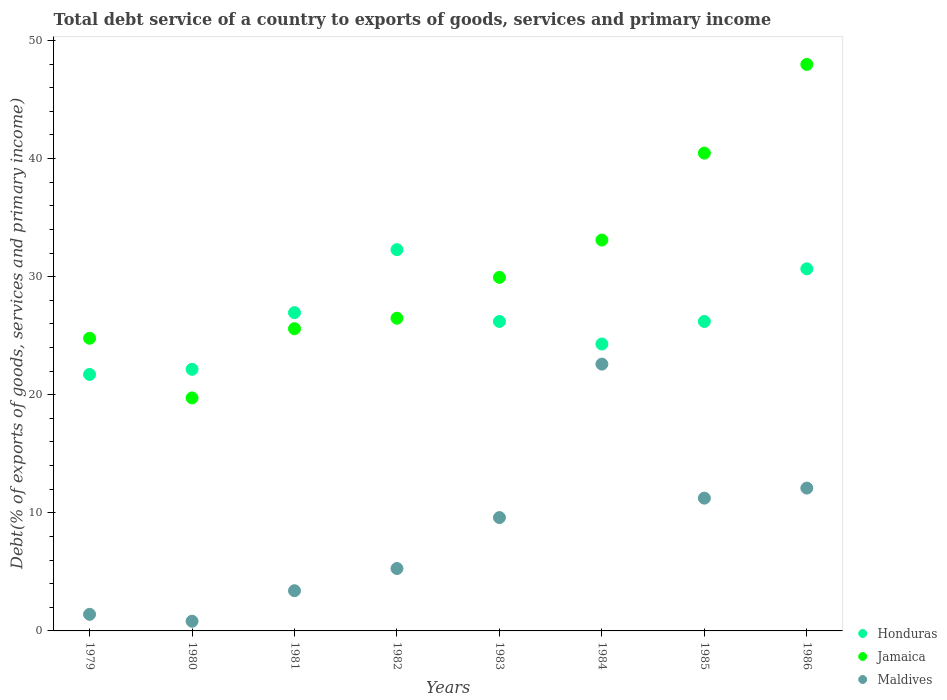What is the total debt service in Maldives in 1981?
Make the answer very short. 3.41. Across all years, what is the maximum total debt service in Honduras?
Ensure brevity in your answer.  32.28. Across all years, what is the minimum total debt service in Maldives?
Offer a very short reply. 0.82. In which year was the total debt service in Jamaica maximum?
Make the answer very short. 1986. In which year was the total debt service in Maldives minimum?
Provide a short and direct response. 1980. What is the total total debt service in Jamaica in the graph?
Give a very brief answer. 248.05. What is the difference between the total debt service in Honduras in 1983 and that in 1984?
Keep it short and to the point. 1.91. What is the difference between the total debt service in Maldives in 1985 and the total debt service in Honduras in 1981?
Make the answer very short. -15.71. What is the average total debt service in Maldives per year?
Offer a very short reply. 8.31. In the year 1983, what is the difference between the total debt service in Jamaica and total debt service in Honduras?
Provide a short and direct response. 3.73. In how many years, is the total debt service in Jamaica greater than 34 %?
Your response must be concise. 2. What is the ratio of the total debt service in Jamaica in 1979 to that in 1980?
Offer a terse response. 1.26. Is the difference between the total debt service in Jamaica in 1984 and 1986 greater than the difference between the total debt service in Honduras in 1984 and 1986?
Ensure brevity in your answer.  No. What is the difference between the highest and the second highest total debt service in Jamaica?
Offer a very short reply. 7.51. What is the difference between the highest and the lowest total debt service in Maldives?
Your answer should be compact. 21.77. Is it the case that in every year, the sum of the total debt service in Honduras and total debt service in Maldives  is greater than the total debt service in Jamaica?
Your answer should be very brief. No. Is the total debt service in Maldives strictly greater than the total debt service in Jamaica over the years?
Ensure brevity in your answer.  No. How many dotlines are there?
Your answer should be compact. 3. How are the legend labels stacked?
Provide a short and direct response. Vertical. What is the title of the graph?
Give a very brief answer. Total debt service of a country to exports of goods, services and primary income. What is the label or title of the X-axis?
Make the answer very short. Years. What is the label or title of the Y-axis?
Make the answer very short. Debt(% of exports of goods, services and primary income). What is the Debt(% of exports of goods, services and primary income) in Honduras in 1979?
Offer a very short reply. 21.72. What is the Debt(% of exports of goods, services and primary income) of Jamaica in 1979?
Provide a succinct answer. 24.78. What is the Debt(% of exports of goods, services and primary income) of Maldives in 1979?
Your response must be concise. 1.4. What is the Debt(% of exports of goods, services and primary income) of Honduras in 1980?
Your answer should be very brief. 22.15. What is the Debt(% of exports of goods, services and primary income) in Jamaica in 1980?
Make the answer very short. 19.73. What is the Debt(% of exports of goods, services and primary income) of Maldives in 1980?
Provide a succinct answer. 0.82. What is the Debt(% of exports of goods, services and primary income) in Honduras in 1981?
Keep it short and to the point. 26.95. What is the Debt(% of exports of goods, services and primary income) in Jamaica in 1981?
Offer a very short reply. 25.59. What is the Debt(% of exports of goods, services and primary income) of Maldives in 1981?
Your answer should be very brief. 3.41. What is the Debt(% of exports of goods, services and primary income) of Honduras in 1982?
Offer a terse response. 32.28. What is the Debt(% of exports of goods, services and primary income) in Jamaica in 1982?
Ensure brevity in your answer.  26.48. What is the Debt(% of exports of goods, services and primary income) in Maldives in 1982?
Your answer should be very brief. 5.28. What is the Debt(% of exports of goods, services and primary income) in Honduras in 1983?
Offer a terse response. 26.2. What is the Debt(% of exports of goods, services and primary income) in Jamaica in 1983?
Offer a terse response. 29.94. What is the Debt(% of exports of goods, services and primary income) of Maldives in 1983?
Make the answer very short. 9.6. What is the Debt(% of exports of goods, services and primary income) of Honduras in 1984?
Your answer should be very brief. 24.29. What is the Debt(% of exports of goods, services and primary income) in Jamaica in 1984?
Offer a very short reply. 33.1. What is the Debt(% of exports of goods, services and primary income) in Maldives in 1984?
Provide a succinct answer. 22.59. What is the Debt(% of exports of goods, services and primary income) in Honduras in 1985?
Provide a succinct answer. 26.2. What is the Debt(% of exports of goods, services and primary income) in Jamaica in 1985?
Provide a succinct answer. 40.46. What is the Debt(% of exports of goods, services and primary income) of Maldives in 1985?
Your answer should be very brief. 11.24. What is the Debt(% of exports of goods, services and primary income) of Honduras in 1986?
Keep it short and to the point. 30.66. What is the Debt(% of exports of goods, services and primary income) in Jamaica in 1986?
Offer a terse response. 47.97. What is the Debt(% of exports of goods, services and primary income) in Maldives in 1986?
Offer a terse response. 12.1. Across all years, what is the maximum Debt(% of exports of goods, services and primary income) of Honduras?
Keep it short and to the point. 32.28. Across all years, what is the maximum Debt(% of exports of goods, services and primary income) in Jamaica?
Give a very brief answer. 47.97. Across all years, what is the maximum Debt(% of exports of goods, services and primary income) of Maldives?
Ensure brevity in your answer.  22.59. Across all years, what is the minimum Debt(% of exports of goods, services and primary income) in Honduras?
Give a very brief answer. 21.72. Across all years, what is the minimum Debt(% of exports of goods, services and primary income) in Jamaica?
Your answer should be compact. 19.73. Across all years, what is the minimum Debt(% of exports of goods, services and primary income) in Maldives?
Your answer should be very brief. 0.82. What is the total Debt(% of exports of goods, services and primary income) of Honduras in the graph?
Give a very brief answer. 210.47. What is the total Debt(% of exports of goods, services and primary income) of Jamaica in the graph?
Offer a very short reply. 248.05. What is the total Debt(% of exports of goods, services and primary income) of Maldives in the graph?
Your answer should be very brief. 66.44. What is the difference between the Debt(% of exports of goods, services and primary income) of Honduras in 1979 and that in 1980?
Your response must be concise. -0.43. What is the difference between the Debt(% of exports of goods, services and primary income) of Jamaica in 1979 and that in 1980?
Your response must be concise. 5.05. What is the difference between the Debt(% of exports of goods, services and primary income) of Maldives in 1979 and that in 1980?
Offer a very short reply. 0.58. What is the difference between the Debt(% of exports of goods, services and primary income) of Honduras in 1979 and that in 1981?
Keep it short and to the point. -5.23. What is the difference between the Debt(% of exports of goods, services and primary income) in Jamaica in 1979 and that in 1981?
Offer a very short reply. -0.81. What is the difference between the Debt(% of exports of goods, services and primary income) of Maldives in 1979 and that in 1981?
Provide a succinct answer. -2. What is the difference between the Debt(% of exports of goods, services and primary income) of Honduras in 1979 and that in 1982?
Give a very brief answer. -10.56. What is the difference between the Debt(% of exports of goods, services and primary income) in Jamaica in 1979 and that in 1982?
Give a very brief answer. -1.7. What is the difference between the Debt(% of exports of goods, services and primary income) in Maldives in 1979 and that in 1982?
Provide a short and direct response. -3.88. What is the difference between the Debt(% of exports of goods, services and primary income) of Honduras in 1979 and that in 1983?
Your answer should be very brief. -4.48. What is the difference between the Debt(% of exports of goods, services and primary income) of Jamaica in 1979 and that in 1983?
Provide a succinct answer. -5.15. What is the difference between the Debt(% of exports of goods, services and primary income) of Maldives in 1979 and that in 1983?
Make the answer very short. -8.19. What is the difference between the Debt(% of exports of goods, services and primary income) of Honduras in 1979 and that in 1984?
Your answer should be compact. -2.58. What is the difference between the Debt(% of exports of goods, services and primary income) in Jamaica in 1979 and that in 1984?
Ensure brevity in your answer.  -8.32. What is the difference between the Debt(% of exports of goods, services and primary income) in Maldives in 1979 and that in 1984?
Your answer should be very brief. -21.19. What is the difference between the Debt(% of exports of goods, services and primary income) in Honduras in 1979 and that in 1985?
Provide a succinct answer. -4.49. What is the difference between the Debt(% of exports of goods, services and primary income) of Jamaica in 1979 and that in 1985?
Provide a succinct answer. -15.68. What is the difference between the Debt(% of exports of goods, services and primary income) of Maldives in 1979 and that in 1985?
Your response must be concise. -9.84. What is the difference between the Debt(% of exports of goods, services and primary income) of Honduras in 1979 and that in 1986?
Make the answer very short. -8.94. What is the difference between the Debt(% of exports of goods, services and primary income) in Jamaica in 1979 and that in 1986?
Offer a very short reply. -23.19. What is the difference between the Debt(% of exports of goods, services and primary income) in Maldives in 1979 and that in 1986?
Make the answer very short. -10.69. What is the difference between the Debt(% of exports of goods, services and primary income) of Honduras in 1980 and that in 1981?
Your answer should be very brief. -4.8. What is the difference between the Debt(% of exports of goods, services and primary income) of Jamaica in 1980 and that in 1981?
Offer a terse response. -5.86. What is the difference between the Debt(% of exports of goods, services and primary income) in Maldives in 1980 and that in 1981?
Your response must be concise. -2.58. What is the difference between the Debt(% of exports of goods, services and primary income) of Honduras in 1980 and that in 1982?
Give a very brief answer. -10.13. What is the difference between the Debt(% of exports of goods, services and primary income) in Jamaica in 1980 and that in 1982?
Make the answer very short. -6.75. What is the difference between the Debt(% of exports of goods, services and primary income) of Maldives in 1980 and that in 1982?
Provide a succinct answer. -4.46. What is the difference between the Debt(% of exports of goods, services and primary income) in Honduras in 1980 and that in 1983?
Offer a very short reply. -4.05. What is the difference between the Debt(% of exports of goods, services and primary income) in Jamaica in 1980 and that in 1983?
Your answer should be compact. -10.21. What is the difference between the Debt(% of exports of goods, services and primary income) of Maldives in 1980 and that in 1983?
Give a very brief answer. -8.78. What is the difference between the Debt(% of exports of goods, services and primary income) of Honduras in 1980 and that in 1984?
Provide a short and direct response. -2.14. What is the difference between the Debt(% of exports of goods, services and primary income) in Jamaica in 1980 and that in 1984?
Ensure brevity in your answer.  -13.37. What is the difference between the Debt(% of exports of goods, services and primary income) in Maldives in 1980 and that in 1984?
Your answer should be compact. -21.77. What is the difference between the Debt(% of exports of goods, services and primary income) of Honduras in 1980 and that in 1985?
Keep it short and to the point. -4.05. What is the difference between the Debt(% of exports of goods, services and primary income) in Jamaica in 1980 and that in 1985?
Make the answer very short. -20.73. What is the difference between the Debt(% of exports of goods, services and primary income) in Maldives in 1980 and that in 1985?
Offer a terse response. -10.42. What is the difference between the Debt(% of exports of goods, services and primary income) of Honduras in 1980 and that in 1986?
Give a very brief answer. -8.51. What is the difference between the Debt(% of exports of goods, services and primary income) of Jamaica in 1980 and that in 1986?
Provide a short and direct response. -28.24. What is the difference between the Debt(% of exports of goods, services and primary income) of Maldives in 1980 and that in 1986?
Keep it short and to the point. -11.27. What is the difference between the Debt(% of exports of goods, services and primary income) of Honduras in 1981 and that in 1982?
Offer a terse response. -5.33. What is the difference between the Debt(% of exports of goods, services and primary income) in Jamaica in 1981 and that in 1982?
Your response must be concise. -0.89. What is the difference between the Debt(% of exports of goods, services and primary income) in Maldives in 1981 and that in 1982?
Provide a succinct answer. -1.88. What is the difference between the Debt(% of exports of goods, services and primary income) in Honduras in 1981 and that in 1983?
Your answer should be very brief. 0.75. What is the difference between the Debt(% of exports of goods, services and primary income) in Jamaica in 1981 and that in 1983?
Make the answer very short. -4.34. What is the difference between the Debt(% of exports of goods, services and primary income) of Maldives in 1981 and that in 1983?
Offer a terse response. -6.19. What is the difference between the Debt(% of exports of goods, services and primary income) of Honduras in 1981 and that in 1984?
Give a very brief answer. 2.66. What is the difference between the Debt(% of exports of goods, services and primary income) of Jamaica in 1981 and that in 1984?
Your response must be concise. -7.51. What is the difference between the Debt(% of exports of goods, services and primary income) in Maldives in 1981 and that in 1984?
Your response must be concise. -19.19. What is the difference between the Debt(% of exports of goods, services and primary income) of Honduras in 1981 and that in 1985?
Give a very brief answer. 0.75. What is the difference between the Debt(% of exports of goods, services and primary income) of Jamaica in 1981 and that in 1985?
Your answer should be very brief. -14.87. What is the difference between the Debt(% of exports of goods, services and primary income) of Maldives in 1981 and that in 1985?
Offer a terse response. -7.84. What is the difference between the Debt(% of exports of goods, services and primary income) in Honduras in 1981 and that in 1986?
Give a very brief answer. -3.71. What is the difference between the Debt(% of exports of goods, services and primary income) of Jamaica in 1981 and that in 1986?
Provide a succinct answer. -22.38. What is the difference between the Debt(% of exports of goods, services and primary income) in Maldives in 1981 and that in 1986?
Provide a short and direct response. -8.69. What is the difference between the Debt(% of exports of goods, services and primary income) of Honduras in 1982 and that in 1983?
Provide a short and direct response. 6.08. What is the difference between the Debt(% of exports of goods, services and primary income) in Jamaica in 1982 and that in 1983?
Offer a terse response. -3.46. What is the difference between the Debt(% of exports of goods, services and primary income) of Maldives in 1982 and that in 1983?
Offer a terse response. -4.31. What is the difference between the Debt(% of exports of goods, services and primary income) of Honduras in 1982 and that in 1984?
Your response must be concise. 7.99. What is the difference between the Debt(% of exports of goods, services and primary income) of Jamaica in 1982 and that in 1984?
Your answer should be compact. -6.62. What is the difference between the Debt(% of exports of goods, services and primary income) in Maldives in 1982 and that in 1984?
Your answer should be very brief. -17.31. What is the difference between the Debt(% of exports of goods, services and primary income) of Honduras in 1982 and that in 1985?
Your response must be concise. 6.08. What is the difference between the Debt(% of exports of goods, services and primary income) in Jamaica in 1982 and that in 1985?
Provide a succinct answer. -13.98. What is the difference between the Debt(% of exports of goods, services and primary income) in Maldives in 1982 and that in 1985?
Your response must be concise. -5.96. What is the difference between the Debt(% of exports of goods, services and primary income) in Honduras in 1982 and that in 1986?
Ensure brevity in your answer.  1.62. What is the difference between the Debt(% of exports of goods, services and primary income) of Jamaica in 1982 and that in 1986?
Offer a terse response. -21.49. What is the difference between the Debt(% of exports of goods, services and primary income) of Maldives in 1982 and that in 1986?
Offer a terse response. -6.81. What is the difference between the Debt(% of exports of goods, services and primary income) in Honduras in 1983 and that in 1984?
Your answer should be very brief. 1.91. What is the difference between the Debt(% of exports of goods, services and primary income) in Jamaica in 1983 and that in 1984?
Keep it short and to the point. -3.16. What is the difference between the Debt(% of exports of goods, services and primary income) in Maldives in 1983 and that in 1984?
Make the answer very short. -12.99. What is the difference between the Debt(% of exports of goods, services and primary income) in Honduras in 1983 and that in 1985?
Give a very brief answer. -0. What is the difference between the Debt(% of exports of goods, services and primary income) in Jamaica in 1983 and that in 1985?
Make the answer very short. -10.52. What is the difference between the Debt(% of exports of goods, services and primary income) of Maldives in 1983 and that in 1985?
Give a very brief answer. -1.64. What is the difference between the Debt(% of exports of goods, services and primary income) in Honduras in 1983 and that in 1986?
Offer a very short reply. -4.46. What is the difference between the Debt(% of exports of goods, services and primary income) of Jamaica in 1983 and that in 1986?
Provide a succinct answer. -18.03. What is the difference between the Debt(% of exports of goods, services and primary income) in Maldives in 1983 and that in 1986?
Your answer should be very brief. -2.5. What is the difference between the Debt(% of exports of goods, services and primary income) of Honduras in 1984 and that in 1985?
Make the answer very short. -1.91. What is the difference between the Debt(% of exports of goods, services and primary income) of Jamaica in 1984 and that in 1985?
Provide a short and direct response. -7.36. What is the difference between the Debt(% of exports of goods, services and primary income) of Maldives in 1984 and that in 1985?
Provide a short and direct response. 11.35. What is the difference between the Debt(% of exports of goods, services and primary income) of Honduras in 1984 and that in 1986?
Make the answer very short. -6.37. What is the difference between the Debt(% of exports of goods, services and primary income) of Jamaica in 1984 and that in 1986?
Give a very brief answer. -14.87. What is the difference between the Debt(% of exports of goods, services and primary income) in Maldives in 1984 and that in 1986?
Ensure brevity in your answer.  10.5. What is the difference between the Debt(% of exports of goods, services and primary income) of Honduras in 1985 and that in 1986?
Your answer should be very brief. -4.46. What is the difference between the Debt(% of exports of goods, services and primary income) of Jamaica in 1985 and that in 1986?
Provide a short and direct response. -7.51. What is the difference between the Debt(% of exports of goods, services and primary income) in Maldives in 1985 and that in 1986?
Offer a very short reply. -0.85. What is the difference between the Debt(% of exports of goods, services and primary income) in Honduras in 1979 and the Debt(% of exports of goods, services and primary income) in Jamaica in 1980?
Provide a succinct answer. 1.99. What is the difference between the Debt(% of exports of goods, services and primary income) in Honduras in 1979 and the Debt(% of exports of goods, services and primary income) in Maldives in 1980?
Keep it short and to the point. 20.9. What is the difference between the Debt(% of exports of goods, services and primary income) of Jamaica in 1979 and the Debt(% of exports of goods, services and primary income) of Maldives in 1980?
Provide a short and direct response. 23.96. What is the difference between the Debt(% of exports of goods, services and primary income) of Honduras in 1979 and the Debt(% of exports of goods, services and primary income) of Jamaica in 1981?
Your answer should be compact. -3.87. What is the difference between the Debt(% of exports of goods, services and primary income) in Honduras in 1979 and the Debt(% of exports of goods, services and primary income) in Maldives in 1981?
Provide a short and direct response. 18.31. What is the difference between the Debt(% of exports of goods, services and primary income) in Jamaica in 1979 and the Debt(% of exports of goods, services and primary income) in Maldives in 1981?
Offer a very short reply. 21.38. What is the difference between the Debt(% of exports of goods, services and primary income) in Honduras in 1979 and the Debt(% of exports of goods, services and primary income) in Jamaica in 1982?
Offer a very short reply. -4.76. What is the difference between the Debt(% of exports of goods, services and primary income) in Honduras in 1979 and the Debt(% of exports of goods, services and primary income) in Maldives in 1982?
Keep it short and to the point. 16.43. What is the difference between the Debt(% of exports of goods, services and primary income) in Jamaica in 1979 and the Debt(% of exports of goods, services and primary income) in Maldives in 1982?
Your answer should be very brief. 19.5. What is the difference between the Debt(% of exports of goods, services and primary income) of Honduras in 1979 and the Debt(% of exports of goods, services and primary income) of Jamaica in 1983?
Provide a succinct answer. -8.22. What is the difference between the Debt(% of exports of goods, services and primary income) of Honduras in 1979 and the Debt(% of exports of goods, services and primary income) of Maldives in 1983?
Provide a succinct answer. 12.12. What is the difference between the Debt(% of exports of goods, services and primary income) of Jamaica in 1979 and the Debt(% of exports of goods, services and primary income) of Maldives in 1983?
Ensure brevity in your answer.  15.18. What is the difference between the Debt(% of exports of goods, services and primary income) of Honduras in 1979 and the Debt(% of exports of goods, services and primary income) of Jamaica in 1984?
Provide a succinct answer. -11.38. What is the difference between the Debt(% of exports of goods, services and primary income) of Honduras in 1979 and the Debt(% of exports of goods, services and primary income) of Maldives in 1984?
Provide a short and direct response. -0.87. What is the difference between the Debt(% of exports of goods, services and primary income) in Jamaica in 1979 and the Debt(% of exports of goods, services and primary income) in Maldives in 1984?
Make the answer very short. 2.19. What is the difference between the Debt(% of exports of goods, services and primary income) of Honduras in 1979 and the Debt(% of exports of goods, services and primary income) of Jamaica in 1985?
Keep it short and to the point. -18.74. What is the difference between the Debt(% of exports of goods, services and primary income) of Honduras in 1979 and the Debt(% of exports of goods, services and primary income) of Maldives in 1985?
Your response must be concise. 10.48. What is the difference between the Debt(% of exports of goods, services and primary income) in Jamaica in 1979 and the Debt(% of exports of goods, services and primary income) in Maldives in 1985?
Keep it short and to the point. 13.54. What is the difference between the Debt(% of exports of goods, services and primary income) in Honduras in 1979 and the Debt(% of exports of goods, services and primary income) in Jamaica in 1986?
Keep it short and to the point. -26.25. What is the difference between the Debt(% of exports of goods, services and primary income) in Honduras in 1979 and the Debt(% of exports of goods, services and primary income) in Maldives in 1986?
Your answer should be very brief. 9.62. What is the difference between the Debt(% of exports of goods, services and primary income) in Jamaica in 1979 and the Debt(% of exports of goods, services and primary income) in Maldives in 1986?
Your answer should be very brief. 12.69. What is the difference between the Debt(% of exports of goods, services and primary income) in Honduras in 1980 and the Debt(% of exports of goods, services and primary income) in Jamaica in 1981?
Offer a very short reply. -3.44. What is the difference between the Debt(% of exports of goods, services and primary income) of Honduras in 1980 and the Debt(% of exports of goods, services and primary income) of Maldives in 1981?
Keep it short and to the point. 18.75. What is the difference between the Debt(% of exports of goods, services and primary income) in Jamaica in 1980 and the Debt(% of exports of goods, services and primary income) in Maldives in 1981?
Ensure brevity in your answer.  16.32. What is the difference between the Debt(% of exports of goods, services and primary income) of Honduras in 1980 and the Debt(% of exports of goods, services and primary income) of Jamaica in 1982?
Provide a short and direct response. -4.33. What is the difference between the Debt(% of exports of goods, services and primary income) in Honduras in 1980 and the Debt(% of exports of goods, services and primary income) in Maldives in 1982?
Keep it short and to the point. 16.87. What is the difference between the Debt(% of exports of goods, services and primary income) in Jamaica in 1980 and the Debt(% of exports of goods, services and primary income) in Maldives in 1982?
Offer a terse response. 14.45. What is the difference between the Debt(% of exports of goods, services and primary income) of Honduras in 1980 and the Debt(% of exports of goods, services and primary income) of Jamaica in 1983?
Give a very brief answer. -7.78. What is the difference between the Debt(% of exports of goods, services and primary income) of Honduras in 1980 and the Debt(% of exports of goods, services and primary income) of Maldives in 1983?
Keep it short and to the point. 12.55. What is the difference between the Debt(% of exports of goods, services and primary income) of Jamaica in 1980 and the Debt(% of exports of goods, services and primary income) of Maldives in 1983?
Offer a terse response. 10.13. What is the difference between the Debt(% of exports of goods, services and primary income) in Honduras in 1980 and the Debt(% of exports of goods, services and primary income) in Jamaica in 1984?
Make the answer very short. -10.95. What is the difference between the Debt(% of exports of goods, services and primary income) in Honduras in 1980 and the Debt(% of exports of goods, services and primary income) in Maldives in 1984?
Make the answer very short. -0.44. What is the difference between the Debt(% of exports of goods, services and primary income) in Jamaica in 1980 and the Debt(% of exports of goods, services and primary income) in Maldives in 1984?
Offer a terse response. -2.86. What is the difference between the Debt(% of exports of goods, services and primary income) of Honduras in 1980 and the Debt(% of exports of goods, services and primary income) of Jamaica in 1985?
Provide a short and direct response. -18.3. What is the difference between the Debt(% of exports of goods, services and primary income) of Honduras in 1980 and the Debt(% of exports of goods, services and primary income) of Maldives in 1985?
Give a very brief answer. 10.91. What is the difference between the Debt(% of exports of goods, services and primary income) in Jamaica in 1980 and the Debt(% of exports of goods, services and primary income) in Maldives in 1985?
Offer a very short reply. 8.49. What is the difference between the Debt(% of exports of goods, services and primary income) in Honduras in 1980 and the Debt(% of exports of goods, services and primary income) in Jamaica in 1986?
Your answer should be very brief. -25.82. What is the difference between the Debt(% of exports of goods, services and primary income) in Honduras in 1980 and the Debt(% of exports of goods, services and primary income) in Maldives in 1986?
Your answer should be very brief. 10.06. What is the difference between the Debt(% of exports of goods, services and primary income) of Jamaica in 1980 and the Debt(% of exports of goods, services and primary income) of Maldives in 1986?
Your answer should be compact. 7.63. What is the difference between the Debt(% of exports of goods, services and primary income) of Honduras in 1981 and the Debt(% of exports of goods, services and primary income) of Jamaica in 1982?
Your answer should be very brief. 0.47. What is the difference between the Debt(% of exports of goods, services and primary income) in Honduras in 1981 and the Debt(% of exports of goods, services and primary income) in Maldives in 1982?
Provide a short and direct response. 21.67. What is the difference between the Debt(% of exports of goods, services and primary income) in Jamaica in 1981 and the Debt(% of exports of goods, services and primary income) in Maldives in 1982?
Make the answer very short. 20.31. What is the difference between the Debt(% of exports of goods, services and primary income) in Honduras in 1981 and the Debt(% of exports of goods, services and primary income) in Jamaica in 1983?
Your answer should be very brief. -2.99. What is the difference between the Debt(% of exports of goods, services and primary income) in Honduras in 1981 and the Debt(% of exports of goods, services and primary income) in Maldives in 1983?
Your answer should be very brief. 17.35. What is the difference between the Debt(% of exports of goods, services and primary income) of Jamaica in 1981 and the Debt(% of exports of goods, services and primary income) of Maldives in 1983?
Provide a short and direct response. 15.99. What is the difference between the Debt(% of exports of goods, services and primary income) of Honduras in 1981 and the Debt(% of exports of goods, services and primary income) of Jamaica in 1984?
Your answer should be very brief. -6.15. What is the difference between the Debt(% of exports of goods, services and primary income) in Honduras in 1981 and the Debt(% of exports of goods, services and primary income) in Maldives in 1984?
Provide a succinct answer. 4.36. What is the difference between the Debt(% of exports of goods, services and primary income) in Jamaica in 1981 and the Debt(% of exports of goods, services and primary income) in Maldives in 1984?
Provide a short and direct response. 3. What is the difference between the Debt(% of exports of goods, services and primary income) of Honduras in 1981 and the Debt(% of exports of goods, services and primary income) of Jamaica in 1985?
Make the answer very short. -13.51. What is the difference between the Debt(% of exports of goods, services and primary income) in Honduras in 1981 and the Debt(% of exports of goods, services and primary income) in Maldives in 1985?
Your answer should be compact. 15.71. What is the difference between the Debt(% of exports of goods, services and primary income) in Jamaica in 1981 and the Debt(% of exports of goods, services and primary income) in Maldives in 1985?
Make the answer very short. 14.35. What is the difference between the Debt(% of exports of goods, services and primary income) in Honduras in 1981 and the Debt(% of exports of goods, services and primary income) in Jamaica in 1986?
Offer a very short reply. -21.02. What is the difference between the Debt(% of exports of goods, services and primary income) of Honduras in 1981 and the Debt(% of exports of goods, services and primary income) of Maldives in 1986?
Provide a short and direct response. 14.86. What is the difference between the Debt(% of exports of goods, services and primary income) in Jamaica in 1981 and the Debt(% of exports of goods, services and primary income) in Maldives in 1986?
Your answer should be compact. 13.5. What is the difference between the Debt(% of exports of goods, services and primary income) in Honduras in 1982 and the Debt(% of exports of goods, services and primary income) in Jamaica in 1983?
Your answer should be very brief. 2.35. What is the difference between the Debt(% of exports of goods, services and primary income) in Honduras in 1982 and the Debt(% of exports of goods, services and primary income) in Maldives in 1983?
Keep it short and to the point. 22.68. What is the difference between the Debt(% of exports of goods, services and primary income) of Jamaica in 1982 and the Debt(% of exports of goods, services and primary income) of Maldives in 1983?
Your answer should be compact. 16.88. What is the difference between the Debt(% of exports of goods, services and primary income) in Honduras in 1982 and the Debt(% of exports of goods, services and primary income) in Jamaica in 1984?
Provide a short and direct response. -0.82. What is the difference between the Debt(% of exports of goods, services and primary income) of Honduras in 1982 and the Debt(% of exports of goods, services and primary income) of Maldives in 1984?
Provide a succinct answer. 9.69. What is the difference between the Debt(% of exports of goods, services and primary income) in Jamaica in 1982 and the Debt(% of exports of goods, services and primary income) in Maldives in 1984?
Make the answer very short. 3.89. What is the difference between the Debt(% of exports of goods, services and primary income) in Honduras in 1982 and the Debt(% of exports of goods, services and primary income) in Jamaica in 1985?
Your response must be concise. -8.17. What is the difference between the Debt(% of exports of goods, services and primary income) in Honduras in 1982 and the Debt(% of exports of goods, services and primary income) in Maldives in 1985?
Ensure brevity in your answer.  21.04. What is the difference between the Debt(% of exports of goods, services and primary income) of Jamaica in 1982 and the Debt(% of exports of goods, services and primary income) of Maldives in 1985?
Keep it short and to the point. 15.24. What is the difference between the Debt(% of exports of goods, services and primary income) of Honduras in 1982 and the Debt(% of exports of goods, services and primary income) of Jamaica in 1986?
Provide a short and direct response. -15.69. What is the difference between the Debt(% of exports of goods, services and primary income) in Honduras in 1982 and the Debt(% of exports of goods, services and primary income) in Maldives in 1986?
Give a very brief answer. 20.19. What is the difference between the Debt(% of exports of goods, services and primary income) in Jamaica in 1982 and the Debt(% of exports of goods, services and primary income) in Maldives in 1986?
Offer a terse response. 14.38. What is the difference between the Debt(% of exports of goods, services and primary income) in Honduras in 1983 and the Debt(% of exports of goods, services and primary income) in Jamaica in 1984?
Make the answer very short. -6.89. What is the difference between the Debt(% of exports of goods, services and primary income) of Honduras in 1983 and the Debt(% of exports of goods, services and primary income) of Maldives in 1984?
Your answer should be compact. 3.61. What is the difference between the Debt(% of exports of goods, services and primary income) in Jamaica in 1983 and the Debt(% of exports of goods, services and primary income) in Maldives in 1984?
Offer a very short reply. 7.35. What is the difference between the Debt(% of exports of goods, services and primary income) of Honduras in 1983 and the Debt(% of exports of goods, services and primary income) of Jamaica in 1985?
Ensure brevity in your answer.  -14.25. What is the difference between the Debt(% of exports of goods, services and primary income) in Honduras in 1983 and the Debt(% of exports of goods, services and primary income) in Maldives in 1985?
Keep it short and to the point. 14.96. What is the difference between the Debt(% of exports of goods, services and primary income) of Jamaica in 1983 and the Debt(% of exports of goods, services and primary income) of Maldives in 1985?
Your response must be concise. 18.69. What is the difference between the Debt(% of exports of goods, services and primary income) in Honduras in 1983 and the Debt(% of exports of goods, services and primary income) in Jamaica in 1986?
Make the answer very short. -21.77. What is the difference between the Debt(% of exports of goods, services and primary income) of Honduras in 1983 and the Debt(% of exports of goods, services and primary income) of Maldives in 1986?
Provide a succinct answer. 14.11. What is the difference between the Debt(% of exports of goods, services and primary income) of Jamaica in 1983 and the Debt(% of exports of goods, services and primary income) of Maldives in 1986?
Keep it short and to the point. 17.84. What is the difference between the Debt(% of exports of goods, services and primary income) in Honduras in 1984 and the Debt(% of exports of goods, services and primary income) in Jamaica in 1985?
Your answer should be very brief. -16.16. What is the difference between the Debt(% of exports of goods, services and primary income) of Honduras in 1984 and the Debt(% of exports of goods, services and primary income) of Maldives in 1985?
Keep it short and to the point. 13.05. What is the difference between the Debt(% of exports of goods, services and primary income) in Jamaica in 1984 and the Debt(% of exports of goods, services and primary income) in Maldives in 1985?
Offer a terse response. 21.85. What is the difference between the Debt(% of exports of goods, services and primary income) in Honduras in 1984 and the Debt(% of exports of goods, services and primary income) in Jamaica in 1986?
Keep it short and to the point. -23.68. What is the difference between the Debt(% of exports of goods, services and primary income) of Honduras in 1984 and the Debt(% of exports of goods, services and primary income) of Maldives in 1986?
Offer a terse response. 12.2. What is the difference between the Debt(% of exports of goods, services and primary income) of Jamaica in 1984 and the Debt(% of exports of goods, services and primary income) of Maldives in 1986?
Keep it short and to the point. 21. What is the difference between the Debt(% of exports of goods, services and primary income) of Honduras in 1985 and the Debt(% of exports of goods, services and primary income) of Jamaica in 1986?
Give a very brief answer. -21.77. What is the difference between the Debt(% of exports of goods, services and primary income) in Honduras in 1985 and the Debt(% of exports of goods, services and primary income) in Maldives in 1986?
Offer a terse response. 14.11. What is the difference between the Debt(% of exports of goods, services and primary income) in Jamaica in 1985 and the Debt(% of exports of goods, services and primary income) in Maldives in 1986?
Offer a terse response. 28.36. What is the average Debt(% of exports of goods, services and primary income) of Honduras per year?
Provide a succinct answer. 26.31. What is the average Debt(% of exports of goods, services and primary income) in Jamaica per year?
Offer a very short reply. 31.01. What is the average Debt(% of exports of goods, services and primary income) in Maldives per year?
Offer a very short reply. 8.31. In the year 1979, what is the difference between the Debt(% of exports of goods, services and primary income) in Honduras and Debt(% of exports of goods, services and primary income) in Jamaica?
Offer a very short reply. -3.06. In the year 1979, what is the difference between the Debt(% of exports of goods, services and primary income) in Honduras and Debt(% of exports of goods, services and primary income) in Maldives?
Give a very brief answer. 20.31. In the year 1979, what is the difference between the Debt(% of exports of goods, services and primary income) of Jamaica and Debt(% of exports of goods, services and primary income) of Maldives?
Your answer should be compact. 23.38. In the year 1980, what is the difference between the Debt(% of exports of goods, services and primary income) of Honduras and Debt(% of exports of goods, services and primary income) of Jamaica?
Make the answer very short. 2.42. In the year 1980, what is the difference between the Debt(% of exports of goods, services and primary income) of Honduras and Debt(% of exports of goods, services and primary income) of Maldives?
Your response must be concise. 21.33. In the year 1980, what is the difference between the Debt(% of exports of goods, services and primary income) of Jamaica and Debt(% of exports of goods, services and primary income) of Maldives?
Your response must be concise. 18.91. In the year 1981, what is the difference between the Debt(% of exports of goods, services and primary income) of Honduras and Debt(% of exports of goods, services and primary income) of Jamaica?
Your answer should be very brief. 1.36. In the year 1981, what is the difference between the Debt(% of exports of goods, services and primary income) of Honduras and Debt(% of exports of goods, services and primary income) of Maldives?
Keep it short and to the point. 23.55. In the year 1981, what is the difference between the Debt(% of exports of goods, services and primary income) in Jamaica and Debt(% of exports of goods, services and primary income) in Maldives?
Offer a terse response. 22.19. In the year 1982, what is the difference between the Debt(% of exports of goods, services and primary income) of Honduras and Debt(% of exports of goods, services and primary income) of Jamaica?
Your response must be concise. 5.8. In the year 1982, what is the difference between the Debt(% of exports of goods, services and primary income) in Honduras and Debt(% of exports of goods, services and primary income) in Maldives?
Offer a very short reply. 27. In the year 1982, what is the difference between the Debt(% of exports of goods, services and primary income) in Jamaica and Debt(% of exports of goods, services and primary income) in Maldives?
Provide a short and direct response. 21.19. In the year 1983, what is the difference between the Debt(% of exports of goods, services and primary income) in Honduras and Debt(% of exports of goods, services and primary income) in Jamaica?
Make the answer very short. -3.73. In the year 1983, what is the difference between the Debt(% of exports of goods, services and primary income) of Honduras and Debt(% of exports of goods, services and primary income) of Maldives?
Give a very brief answer. 16.6. In the year 1983, what is the difference between the Debt(% of exports of goods, services and primary income) of Jamaica and Debt(% of exports of goods, services and primary income) of Maldives?
Provide a succinct answer. 20.34. In the year 1984, what is the difference between the Debt(% of exports of goods, services and primary income) of Honduras and Debt(% of exports of goods, services and primary income) of Jamaica?
Provide a succinct answer. -8.8. In the year 1984, what is the difference between the Debt(% of exports of goods, services and primary income) of Honduras and Debt(% of exports of goods, services and primary income) of Maldives?
Give a very brief answer. 1.7. In the year 1984, what is the difference between the Debt(% of exports of goods, services and primary income) of Jamaica and Debt(% of exports of goods, services and primary income) of Maldives?
Ensure brevity in your answer.  10.51. In the year 1985, what is the difference between the Debt(% of exports of goods, services and primary income) in Honduras and Debt(% of exports of goods, services and primary income) in Jamaica?
Keep it short and to the point. -14.25. In the year 1985, what is the difference between the Debt(% of exports of goods, services and primary income) of Honduras and Debt(% of exports of goods, services and primary income) of Maldives?
Your answer should be very brief. 14.96. In the year 1985, what is the difference between the Debt(% of exports of goods, services and primary income) in Jamaica and Debt(% of exports of goods, services and primary income) in Maldives?
Provide a succinct answer. 29.21. In the year 1986, what is the difference between the Debt(% of exports of goods, services and primary income) in Honduras and Debt(% of exports of goods, services and primary income) in Jamaica?
Your response must be concise. -17.31. In the year 1986, what is the difference between the Debt(% of exports of goods, services and primary income) of Honduras and Debt(% of exports of goods, services and primary income) of Maldives?
Your answer should be very brief. 18.57. In the year 1986, what is the difference between the Debt(% of exports of goods, services and primary income) in Jamaica and Debt(% of exports of goods, services and primary income) in Maldives?
Make the answer very short. 35.87. What is the ratio of the Debt(% of exports of goods, services and primary income) of Honduras in 1979 to that in 1980?
Make the answer very short. 0.98. What is the ratio of the Debt(% of exports of goods, services and primary income) of Jamaica in 1979 to that in 1980?
Ensure brevity in your answer.  1.26. What is the ratio of the Debt(% of exports of goods, services and primary income) in Maldives in 1979 to that in 1980?
Your answer should be very brief. 1.71. What is the ratio of the Debt(% of exports of goods, services and primary income) in Honduras in 1979 to that in 1981?
Provide a short and direct response. 0.81. What is the ratio of the Debt(% of exports of goods, services and primary income) of Jamaica in 1979 to that in 1981?
Your answer should be compact. 0.97. What is the ratio of the Debt(% of exports of goods, services and primary income) of Maldives in 1979 to that in 1981?
Provide a short and direct response. 0.41. What is the ratio of the Debt(% of exports of goods, services and primary income) of Honduras in 1979 to that in 1982?
Keep it short and to the point. 0.67. What is the ratio of the Debt(% of exports of goods, services and primary income) of Jamaica in 1979 to that in 1982?
Offer a very short reply. 0.94. What is the ratio of the Debt(% of exports of goods, services and primary income) in Maldives in 1979 to that in 1982?
Provide a short and direct response. 0.27. What is the ratio of the Debt(% of exports of goods, services and primary income) of Honduras in 1979 to that in 1983?
Offer a very short reply. 0.83. What is the ratio of the Debt(% of exports of goods, services and primary income) in Jamaica in 1979 to that in 1983?
Provide a short and direct response. 0.83. What is the ratio of the Debt(% of exports of goods, services and primary income) in Maldives in 1979 to that in 1983?
Offer a terse response. 0.15. What is the ratio of the Debt(% of exports of goods, services and primary income) of Honduras in 1979 to that in 1984?
Your answer should be compact. 0.89. What is the ratio of the Debt(% of exports of goods, services and primary income) in Jamaica in 1979 to that in 1984?
Offer a very short reply. 0.75. What is the ratio of the Debt(% of exports of goods, services and primary income) of Maldives in 1979 to that in 1984?
Provide a short and direct response. 0.06. What is the ratio of the Debt(% of exports of goods, services and primary income) of Honduras in 1979 to that in 1985?
Provide a short and direct response. 0.83. What is the ratio of the Debt(% of exports of goods, services and primary income) in Jamaica in 1979 to that in 1985?
Your response must be concise. 0.61. What is the ratio of the Debt(% of exports of goods, services and primary income) in Maldives in 1979 to that in 1985?
Your answer should be very brief. 0.12. What is the ratio of the Debt(% of exports of goods, services and primary income) in Honduras in 1979 to that in 1986?
Provide a short and direct response. 0.71. What is the ratio of the Debt(% of exports of goods, services and primary income) of Jamaica in 1979 to that in 1986?
Keep it short and to the point. 0.52. What is the ratio of the Debt(% of exports of goods, services and primary income) of Maldives in 1979 to that in 1986?
Ensure brevity in your answer.  0.12. What is the ratio of the Debt(% of exports of goods, services and primary income) of Honduras in 1980 to that in 1981?
Your answer should be compact. 0.82. What is the ratio of the Debt(% of exports of goods, services and primary income) of Jamaica in 1980 to that in 1981?
Make the answer very short. 0.77. What is the ratio of the Debt(% of exports of goods, services and primary income) in Maldives in 1980 to that in 1981?
Your answer should be very brief. 0.24. What is the ratio of the Debt(% of exports of goods, services and primary income) of Honduras in 1980 to that in 1982?
Provide a succinct answer. 0.69. What is the ratio of the Debt(% of exports of goods, services and primary income) of Jamaica in 1980 to that in 1982?
Offer a very short reply. 0.75. What is the ratio of the Debt(% of exports of goods, services and primary income) in Maldives in 1980 to that in 1982?
Provide a succinct answer. 0.16. What is the ratio of the Debt(% of exports of goods, services and primary income) in Honduras in 1980 to that in 1983?
Your answer should be very brief. 0.85. What is the ratio of the Debt(% of exports of goods, services and primary income) in Jamaica in 1980 to that in 1983?
Give a very brief answer. 0.66. What is the ratio of the Debt(% of exports of goods, services and primary income) in Maldives in 1980 to that in 1983?
Make the answer very short. 0.09. What is the ratio of the Debt(% of exports of goods, services and primary income) of Honduras in 1980 to that in 1984?
Your response must be concise. 0.91. What is the ratio of the Debt(% of exports of goods, services and primary income) in Jamaica in 1980 to that in 1984?
Your response must be concise. 0.6. What is the ratio of the Debt(% of exports of goods, services and primary income) of Maldives in 1980 to that in 1984?
Provide a succinct answer. 0.04. What is the ratio of the Debt(% of exports of goods, services and primary income) in Honduras in 1980 to that in 1985?
Keep it short and to the point. 0.85. What is the ratio of the Debt(% of exports of goods, services and primary income) in Jamaica in 1980 to that in 1985?
Make the answer very short. 0.49. What is the ratio of the Debt(% of exports of goods, services and primary income) of Maldives in 1980 to that in 1985?
Keep it short and to the point. 0.07. What is the ratio of the Debt(% of exports of goods, services and primary income) of Honduras in 1980 to that in 1986?
Provide a short and direct response. 0.72. What is the ratio of the Debt(% of exports of goods, services and primary income) of Jamaica in 1980 to that in 1986?
Offer a terse response. 0.41. What is the ratio of the Debt(% of exports of goods, services and primary income) of Maldives in 1980 to that in 1986?
Make the answer very short. 0.07. What is the ratio of the Debt(% of exports of goods, services and primary income) in Honduras in 1981 to that in 1982?
Your response must be concise. 0.83. What is the ratio of the Debt(% of exports of goods, services and primary income) in Jamaica in 1981 to that in 1982?
Your response must be concise. 0.97. What is the ratio of the Debt(% of exports of goods, services and primary income) of Maldives in 1981 to that in 1982?
Give a very brief answer. 0.64. What is the ratio of the Debt(% of exports of goods, services and primary income) of Honduras in 1981 to that in 1983?
Ensure brevity in your answer.  1.03. What is the ratio of the Debt(% of exports of goods, services and primary income) in Jamaica in 1981 to that in 1983?
Give a very brief answer. 0.85. What is the ratio of the Debt(% of exports of goods, services and primary income) in Maldives in 1981 to that in 1983?
Keep it short and to the point. 0.35. What is the ratio of the Debt(% of exports of goods, services and primary income) of Honduras in 1981 to that in 1984?
Your response must be concise. 1.11. What is the ratio of the Debt(% of exports of goods, services and primary income) of Jamaica in 1981 to that in 1984?
Make the answer very short. 0.77. What is the ratio of the Debt(% of exports of goods, services and primary income) of Maldives in 1981 to that in 1984?
Offer a terse response. 0.15. What is the ratio of the Debt(% of exports of goods, services and primary income) of Honduras in 1981 to that in 1985?
Offer a very short reply. 1.03. What is the ratio of the Debt(% of exports of goods, services and primary income) in Jamaica in 1981 to that in 1985?
Make the answer very short. 0.63. What is the ratio of the Debt(% of exports of goods, services and primary income) of Maldives in 1981 to that in 1985?
Make the answer very short. 0.3. What is the ratio of the Debt(% of exports of goods, services and primary income) of Honduras in 1981 to that in 1986?
Give a very brief answer. 0.88. What is the ratio of the Debt(% of exports of goods, services and primary income) in Jamaica in 1981 to that in 1986?
Ensure brevity in your answer.  0.53. What is the ratio of the Debt(% of exports of goods, services and primary income) in Maldives in 1981 to that in 1986?
Provide a short and direct response. 0.28. What is the ratio of the Debt(% of exports of goods, services and primary income) of Honduras in 1982 to that in 1983?
Provide a short and direct response. 1.23. What is the ratio of the Debt(% of exports of goods, services and primary income) in Jamaica in 1982 to that in 1983?
Offer a very short reply. 0.88. What is the ratio of the Debt(% of exports of goods, services and primary income) of Maldives in 1982 to that in 1983?
Ensure brevity in your answer.  0.55. What is the ratio of the Debt(% of exports of goods, services and primary income) in Honduras in 1982 to that in 1984?
Ensure brevity in your answer.  1.33. What is the ratio of the Debt(% of exports of goods, services and primary income) in Maldives in 1982 to that in 1984?
Your answer should be compact. 0.23. What is the ratio of the Debt(% of exports of goods, services and primary income) of Honduras in 1982 to that in 1985?
Offer a terse response. 1.23. What is the ratio of the Debt(% of exports of goods, services and primary income) in Jamaica in 1982 to that in 1985?
Your answer should be very brief. 0.65. What is the ratio of the Debt(% of exports of goods, services and primary income) in Maldives in 1982 to that in 1985?
Ensure brevity in your answer.  0.47. What is the ratio of the Debt(% of exports of goods, services and primary income) of Honduras in 1982 to that in 1986?
Your answer should be very brief. 1.05. What is the ratio of the Debt(% of exports of goods, services and primary income) in Jamaica in 1982 to that in 1986?
Keep it short and to the point. 0.55. What is the ratio of the Debt(% of exports of goods, services and primary income) in Maldives in 1982 to that in 1986?
Give a very brief answer. 0.44. What is the ratio of the Debt(% of exports of goods, services and primary income) in Honduras in 1983 to that in 1984?
Give a very brief answer. 1.08. What is the ratio of the Debt(% of exports of goods, services and primary income) in Jamaica in 1983 to that in 1984?
Your answer should be compact. 0.9. What is the ratio of the Debt(% of exports of goods, services and primary income) of Maldives in 1983 to that in 1984?
Offer a terse response. 0.42. What is the ratio of the Debt(% of exports of goods, services and primary income) of Honduras in 1983 to that in 1985?
Your answer should be compact. 1. What is the ratio of the Debt(% of exports of goods, services and primary income) in Jamaica in 1983 to that in 1985?
Make the answer very short. 0.74. What is the ratio of the Debt(% of exports of goods, services and primary income) in Maldives in 1983 to that in 1985?
Give a very brief answer. 0.85. What is the ratio of the Debt(% of exports of goods, services and primary income) of Honduras in 1983 to that in 1986?
Provide a short and direct response. 0.85. What is the ratio of the Debt(% of exports of goods, services and primary income) in Jamaica in 1983 to that in 1986?
Provide a short and direct response. 0.62. What is the ratio of the Debt(% of exports of goods, services and primary income) in Maldives in 1983 to that in 1986?
Your answer should be very brief. 0.79. What is the ratio of the Debt(% of exports of goods, services and primary income) in Honduras in 1984 to that in 1985?
Your answer should be very brief. 0.93. What is the ratio of the Debt(% of exports of goods, services and primary income) in Jamaica in 1984 to that in 1985?
Provide a succinct answer. 0.82. What is the ratio of the Debt(% of exports of goods, services and primary income) of Maldives in 1984 to that in 1985?
Ensure brevity in your answer.  2.01. What is the ratio of the Debt(% of exports of goods, services and primary income) in Honduras in 1984 to that in 1986?
Provide a short and direct response. 0.79. What is the ratio of the Debt(% of exports of goods, services and primary income) of Jamaica in 1984 to that in 1986?
Make the answer very short. 0.69. What is the ratio of the Debt(% of exports of goods, services and primary income) in Maldives in 1984 to that in 1986?
Keep it short and to the point. 1.87. What is the ratio of the Debt(% of exports of goods, services and primary income) in Honduras in 1985 to that in 1986?
Give a very brief answer. 0.85. What is the ratio of the Debt(% of exports of goods, services and primary income) in Jamaica in 1985 to that in 1986?
Give a very brief answer. 0.84. What is the ratio of the Debt(% of exports of goods, services and primary income) of Maldives in 1985 to that in 1986?
Make the answer very short. 0.93. What is the difference between the highest and the second highest Debt(% of exports of goods, services and primary income) in Honduras?
Offer a terse response. 1.62. What is the difference between the highest and the second highest Debt(% of exports of goods, services and primary income) in Jamaica?
Offer a terse response. 7.51. What is the difference between the highest and the second highest Debt(% of exports of goods, services and primary income) in Maldives?
Your answer should be very brief. 10.5. What is the difference between the highest and the lowest Debt(% of exports of goods, services and primary income) in Honduras?
Your answer should be very brief. 10.56. What is the difference between the highest and the lowest Debt(% of exports of goods, services and primary income) of Jamaica?
Keep it short and to the point. 28.24. What is the difference between the highest and the lowest Debt(% of exports of goods, services and primary income) in Maldives?
Make the answer very short. 21.77. 